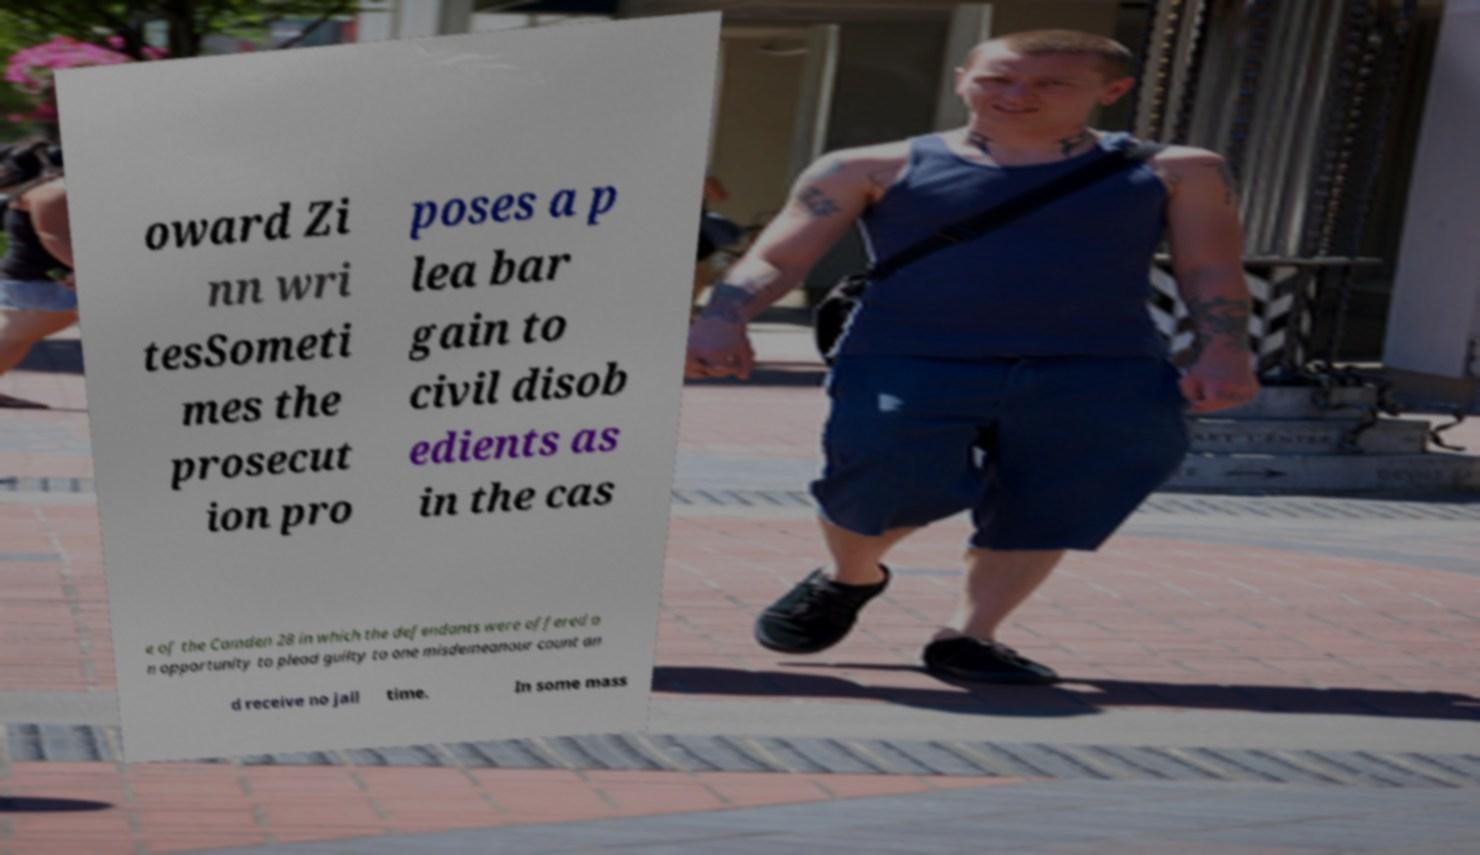Could you assist in decoding the text presented in this image and type it out clearly? oward Zi nn wri tesSometi mes the prosecut ion pro poses a p lea bar gain to civil disob edients as in the cas e of the Camden 28 in which the defendants were offered a n opportunity to plead guilty to one misdemeanour count an d receive no jail time. In some mass 